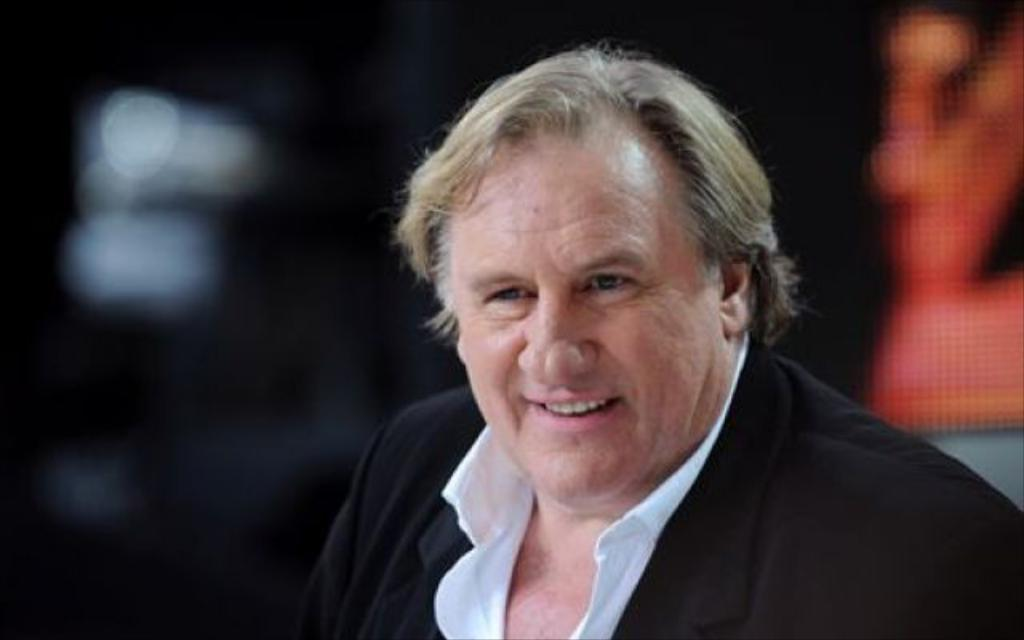Who is the main subject in the image? There is a man in the center of the image. Can you describe the background of the image? The background of the image is blurry. Can you see a river flowing in the background of the image? There is no river visible in the image; the background is blurry. 